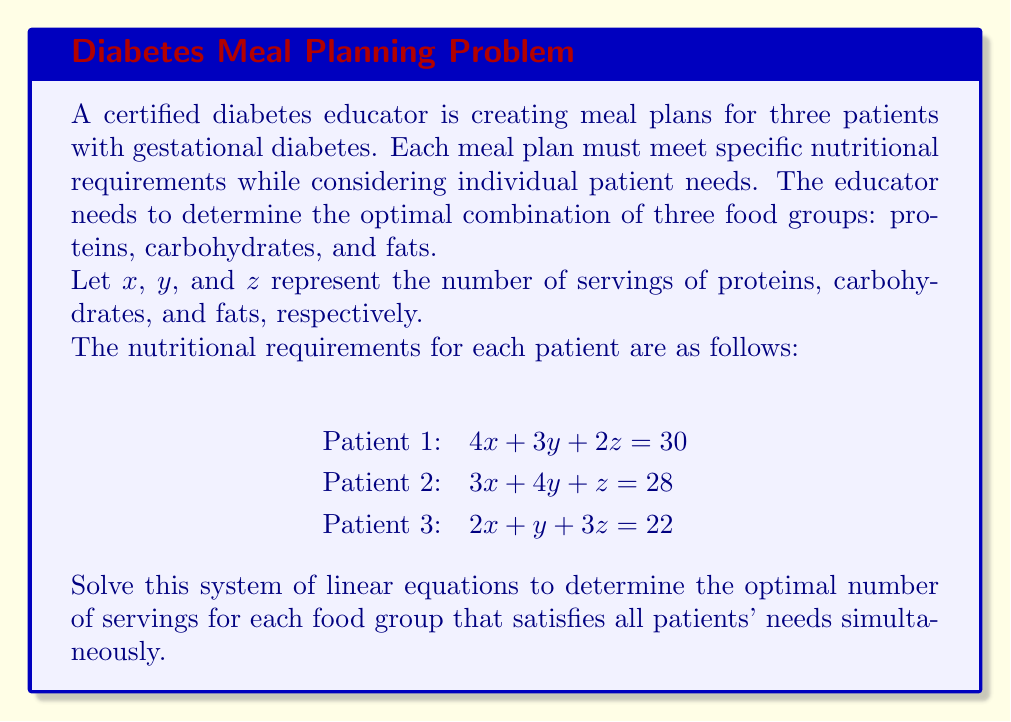Can you answer this question? To solve this system of linear equations, we'll use the Gaussian elimination method:

1) First, write the augmented matrix:

   $$\begin{bmatrix}
   4 & 3 & 2 & 30 \\
   3 & 4 & 1 & 28 \\
   2 & 1 & 3 & 22
   \end{bmatrix}$$

2) Multiply the first row by $-\frac{3}{4}$ and add it to the second row:

   $$\begin{bmatrix}
   4 & 3 & 2 & 30 \\
   0 & \frac{7}{4} & -\frac{1}{2} & \frac{15}{2} \\
   2 & 1 & 3 & 22
   \end{bmatrix}$$

3) Multiply the first row by $-\frac{1}{2}$ and add it to the third row:

   $$\begin{bmatrix}
   4 & 3 & 2 & 30 \\
   0 & \frac{7}{4} & -\frac{1}{2} & \frac{15}{2} \\
   0 & -\frac{1}{2} & 2 & 7
   \end{bmatrix}$$

4) Multiply the second row by $\frac{2}{7}$ and add it to the third row:

   $$\begin{bmatrix}
   4 & 3 & 2 & 30 \\
   0 & \frac{7}{4} & -\frac{1}{2} & \frac{15}{2} \\
   0 & 0 & \frac{15}{7} & \frac{77}{7}
   \end{bmatrix}$$

5) Now we have an upper triangular matrix. We can solve for $z$:

   $\frac{15}{7}z = \frac{77}{7}$
   $z = \frac{77}{15} = 5.1333...$

6) Substitute this value in the second equation:

   $\frac{7}{4}y - \frac{1}{2}(5.1333...) = \frac{15}{2}$
   $\frac{7}{4}y = \frac{15}{2} + \frac{5.1333...}{2} = 10.0667...$
   $y = \frac{40.2667...}{7} = 5.7524...$

7) Finally, substitute these values in the first equation:

   $4x + 3(5.7524...) + 2(5.1333...) = 30$
   $4x = 30 - 17.2572... - 10.2666... = 2.4762...$
   $x = 0.6190...$

Therefore, the solution is approximately:
$x \approx 0.6190$
$y \approx 5.7524$
$z \approx 5.1333$
Answer: The optimal meal plan should include approximately 0.62 servings of protein, 5.75 servings of carbohydrates, and 5.13 servings of fats. 